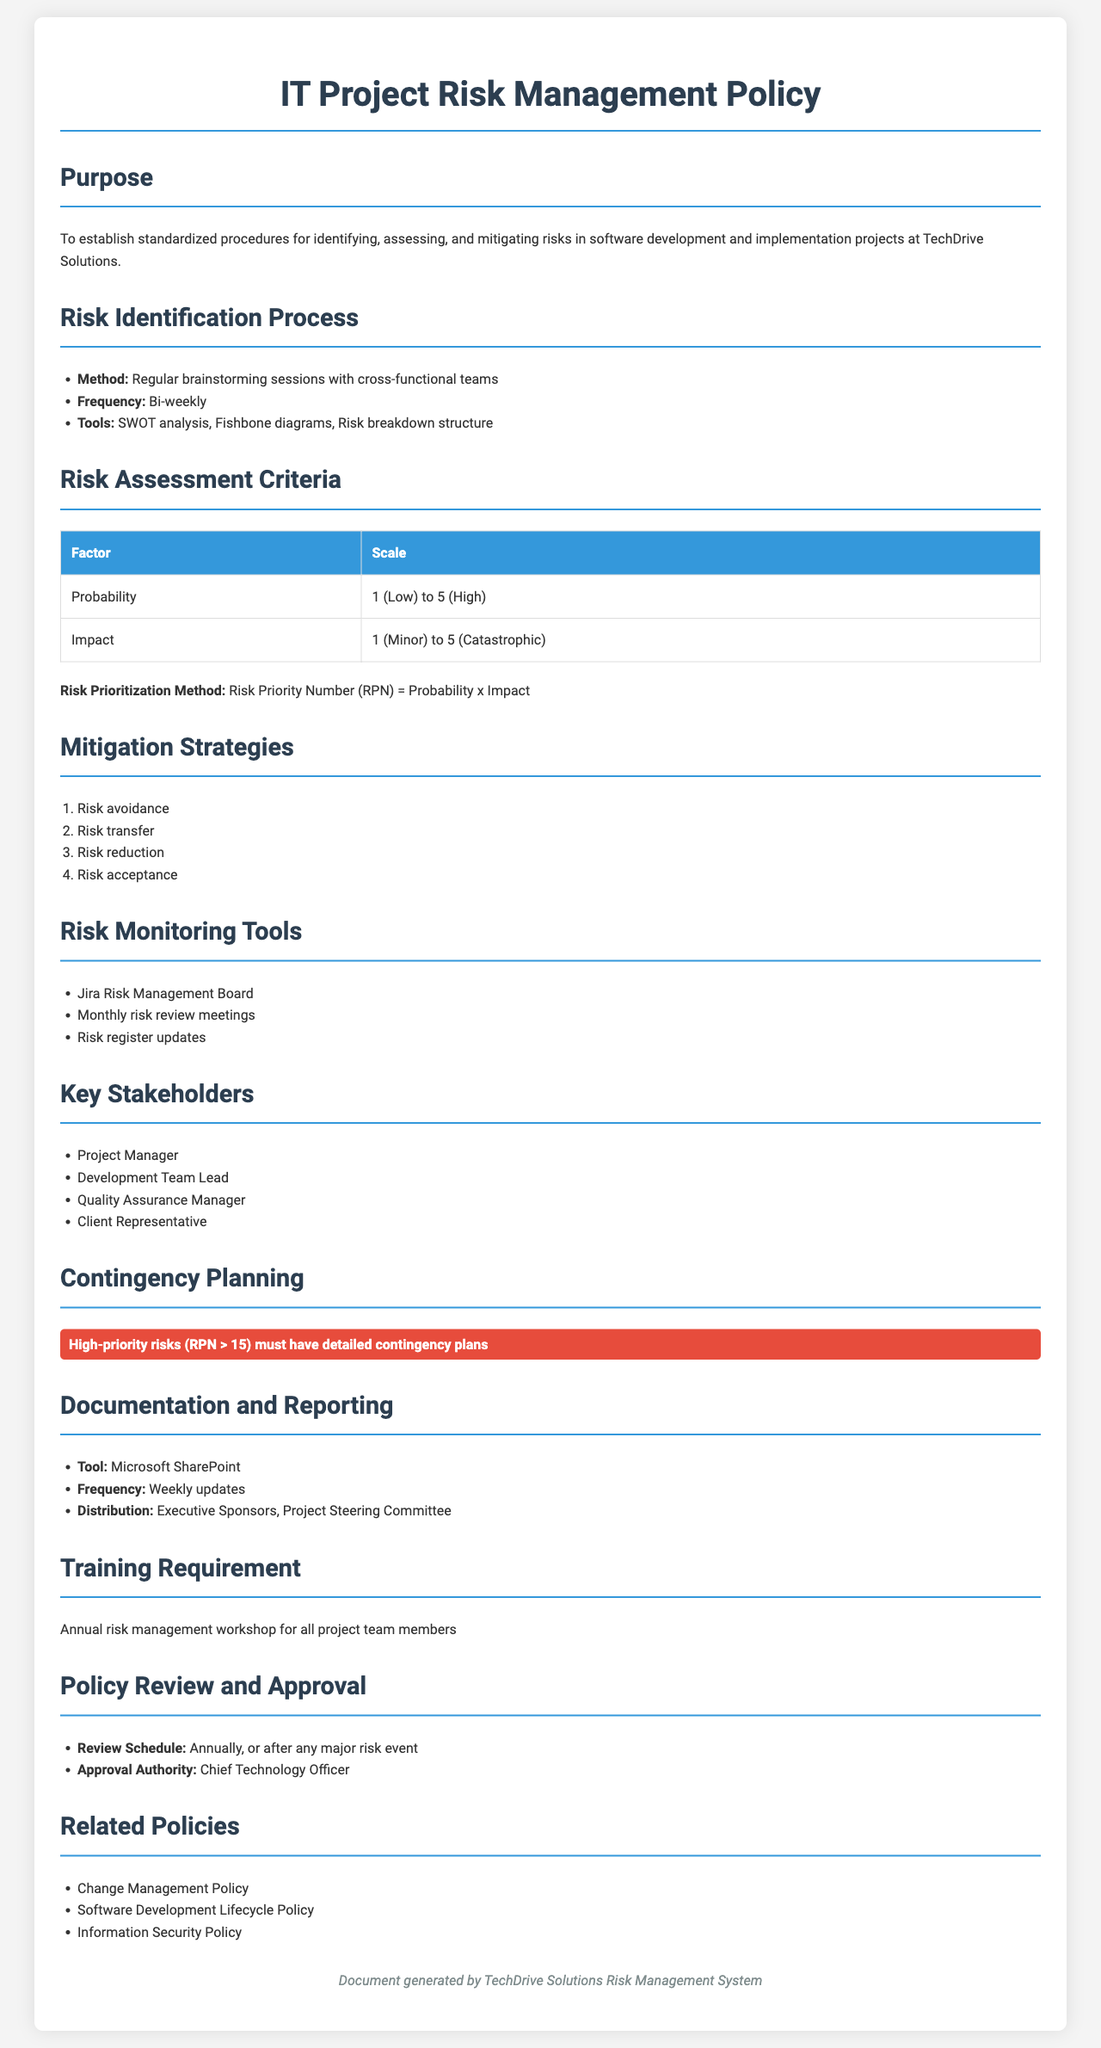What is the purpose of the IT Project Risk Management Policy? The purpose is to establish standardized procedures for identifying, assessing, and mitigating risks in software development and implementation projects at TechDrive Solutions.
Answer: Establish standardized procedures How often are risk identification sessions held? The document states that risk identification sessions are held bi-weekly.
Answer: Bi-weekly What is the maximum value on the probability scale for risk assessment? The document indicates that the maximum value on the probability scale is 5.
Answer: 5 Which tool is used for documentation and reporting? The document specifies Microsoft SharePoint as the tool for documentation and reporting.
Answer: Microsoft SharePoint Who is the approval authority for the policy? According to the document, the approval authority is the Chief Technology Officer.
Answer: Chief Technology Officer What must high-priority risks have according to the contingency planning section? The document highlights that high-priority risks (RPN > 15) must have detailed contingency plans.
Answer: Detailed contingency plans What scale is used to assess the impact of risks? The document indicates that the impact scale ranges from 1 (Minor) to 5 (Catastrophic).
Answer: 1 to 5 Name one mitigation strategy listed in the document. The document lists several strategies; for instance, risk avoidance is one of them.
Answer: Risk avoidance What is the frequency of updates mentioned for documentation? The document states that updates should occur weekly.
Answer: Weekly 